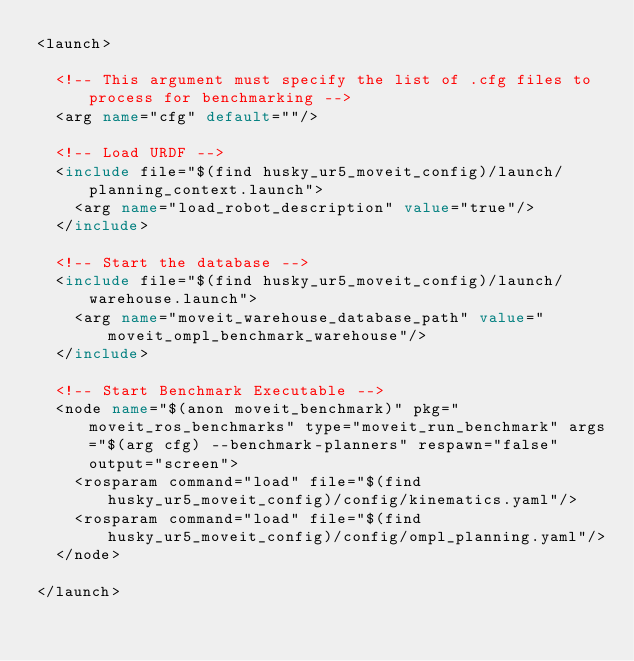Convert code to text. <code><loc_0><loc_0><loc_500><loc_500><_XML_><launch>

  <!-- This argument must specify the list of .cfg files to process for benchmarking -->
  <arg name="cfg" default=""/>

  <!-- Load URDF -->
  <include file="$(find husky_ur5_moveit_config)/launch/planning_context.launch">
    <arg name="load_robot_description" value="true"/>
  </include>

  <!-- Start the database -->
  <include file="$(find husky_ur5_moveit_config)/launch/warehouse.launch">
    <arg name="moveit_warehouse_database_path" value="moveit_ompl_benchmark_warehouse"/>
  </include>  

  <!-- Start Benchmark Executable -->
  <node name="$(anon moveit_benchmark)" pkg="moveit_ros_benchmarks" type="moveit_run_benchmark" args="$(arg cfg) --benchmark-planners" respawn="false" output="screen">
    <rosparam command="load" file="$(find husky_ur5_moveit_config)/config/kinematics.yaml"/>
    <rosparam command="load" file="$(find husky_ur5_moveit_config)/config/ompl_planning.yaml"/>
  </node>

</launch>
</code> 